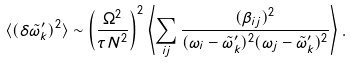<formula> <loc_0><loc_0><loc_500><loc_500>\langle ( \delta \tilde { \omega } ^ { \prime } _ { k } ) ^ { 2 } \rangle \sim \left ( \frac { \Omega ^ { 2 } } { \tau N ^ { 2 } } \right ) ^ { 2 } \left \langle \sum _ { i j } \frac { ( \beta _ { i j } ) ^ { 2 } } { ( \omega _ { i } - \tilde { \omega } ^ { \prime } _ { k } ) ^ { 2 } ( \omega _ { j } - \tilde { \omega } ^ { \prime } _ { k } ) ^ { 2 } } \right \rangle .</formula> 